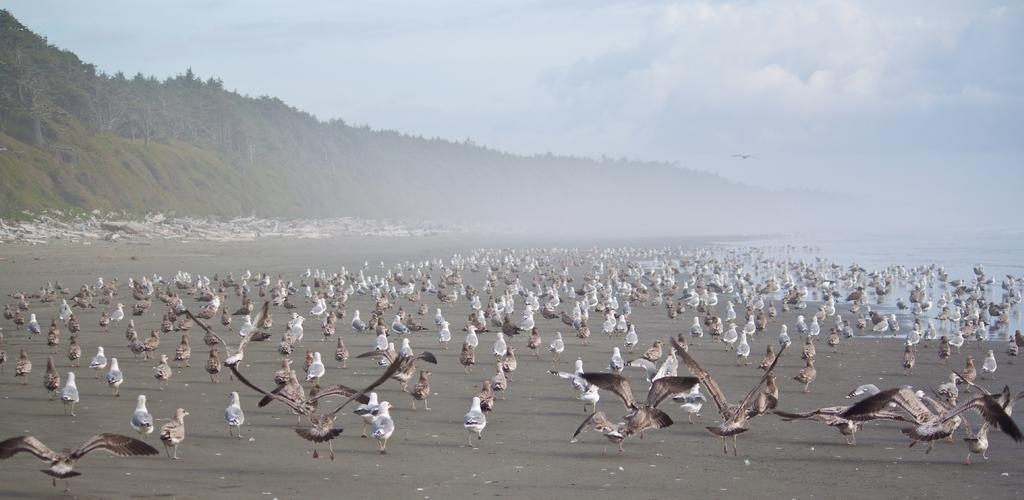What is located in the center of the image? There are birds in the center of the image. Where are the birds situated? The birds are on the sea shore. What can be seen in the background of the image? There are trees and the sky visible in the background of the image. What is present on the right side of the image? There is water on the right side of the image. What is the bird writing on the sand in the image? Birds do not have the ability to write, and there is no writing visible in the image. 